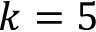Convert formula to latex. <formula><loc_0><loc_0><loc_500><loc_500>k = 5</formula> 